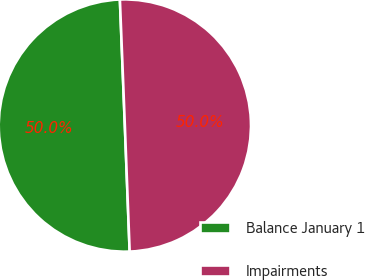Convert chart. <chart><loc_0><loc_0><loc_500><loc_500><pie_chart><fcel>Balance January 1<fcel>Impairments<nl><fcel>49.98%<fcel>50.02%<nl></chart> 